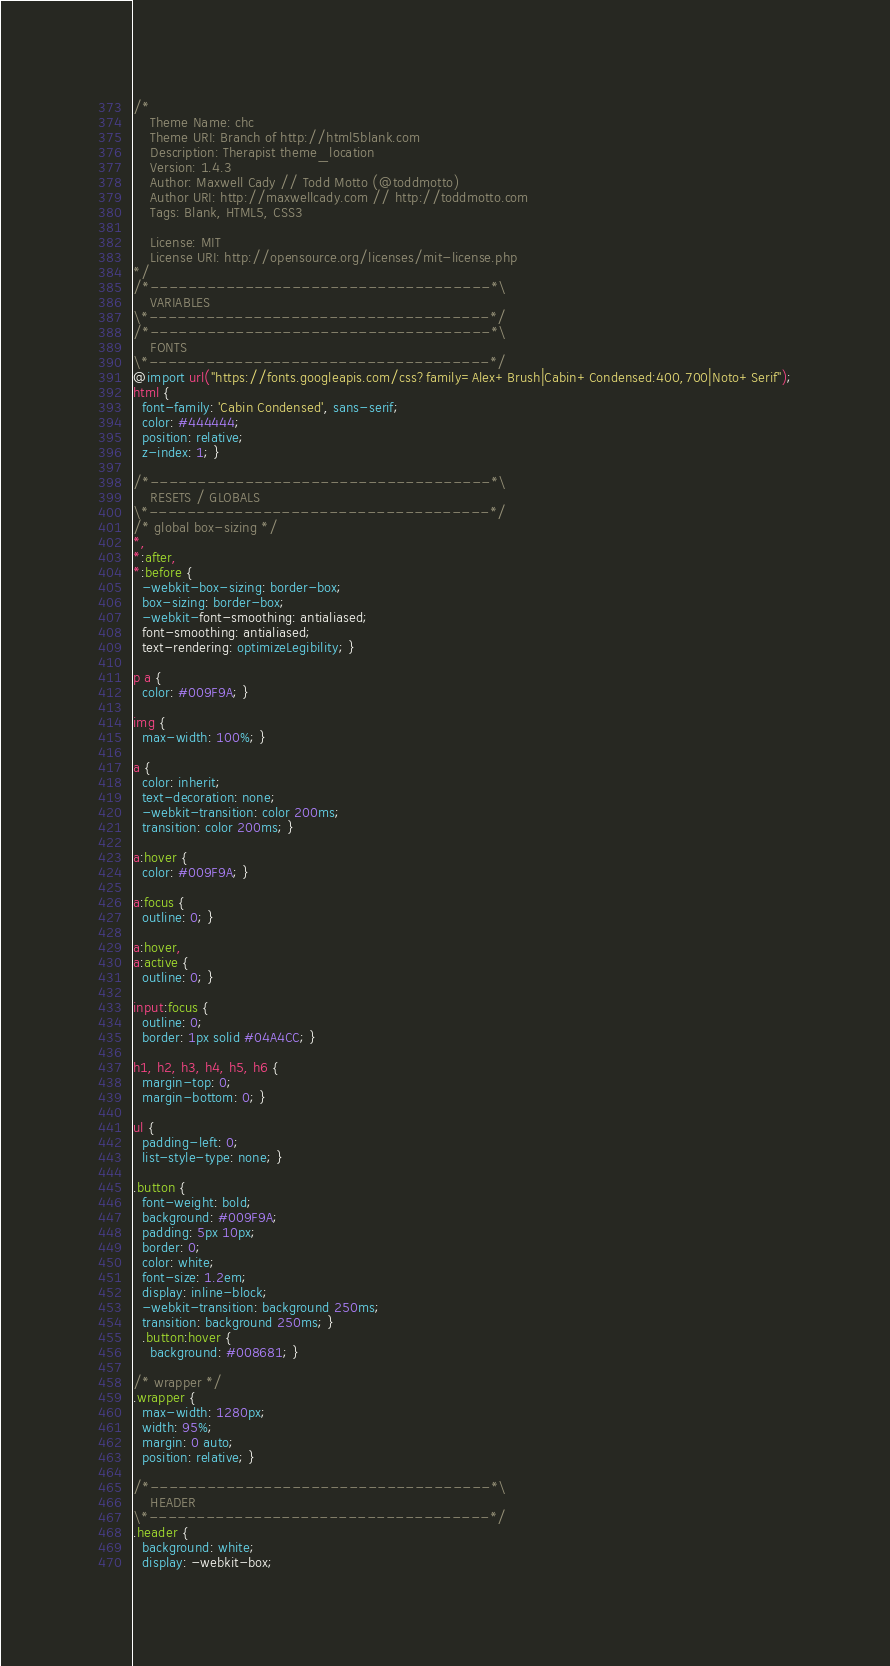Convert code to text. <code><loc_0><loc_0><loc_500><loc_500><_CSS_>/*
	Theme Name: chc
	Theme URI: Branch of http://html5blank.com
	Description: Therapist theme_location
	Version: 1.4.3
	Author: Maxwell Cady // Todd Motto (@toddmotto)
	Author URI: http://maxwellcady.com // http://toddmotto.com
	Tags: Blank, HTML5, CSS3

	License: MIT
	License URI: http://opensource.org/licenses/mit-license.php
*/
/*------------------------------------*\
    VARIABLES
\*------------------------------------*/
/*------------------------------------*\
    FONTS
\*------------------------------------*/
@import url("https://fonts.googleapis.com/css?family=Alex+Brush|Cabin+Condensed:400,700|Noto+Serif");
html {
  font-family: 'Cabin Condensed', sans-serif;
  color: #444444;
  position: relative;
  z-index: 1; }

/*------------------------------------*\
    RESETS / GLOBALS
\*------------------------------------*/
/* global box-sizing */
*,
*:after,
*:before {
  -webkit-box-sizing: border-box;
  box-sizing: border-box;
  -webkit-font-smoothing: antialiased;
  font-smoothing: antialiased;
  text-rendering: optimizeLegibility; }

p a {
  color: #009F9A; }

img {
  max-width: 100%; }

a {
  color: inherit;
  text-decoration: none;
  -webkit-transition: color 200ms;
  transition: color 200ms; }

a:hover {
  color: #009F9A; }

a:focus {
  outline: 0; }

a:hover,
a:active {
  outline: 0; }

input:focus {
  outline: 0;
  border: 1px solid #04A4CC; }

h1, h2, h3, h4, h5, h6 {
  margin-top: 0;
  margin-bottom: 0; }

ul {
  padding-left: 0;
  list-style-type: none; }

.button {
  font-weight: bold;
  background: #009F9A;
  padding: 5px 10px;
  border: 0;
  color: white;
  font-size: 1.2em;
  display: inline-block;
  -webkit-transition: background 250ms;
  transition: background 250ms; }
  .button:hover {
    background: #008681; }

/* wrapper */
.wrapper {
  max-width: 1280px;
  width: 95%;
  margin: 0 auto;
  position: relative; }

/*------------------------------------*\
    HEADER
\*------------------------------------*/
.header {
  background: white;
  display: -webkit-box;</code> 